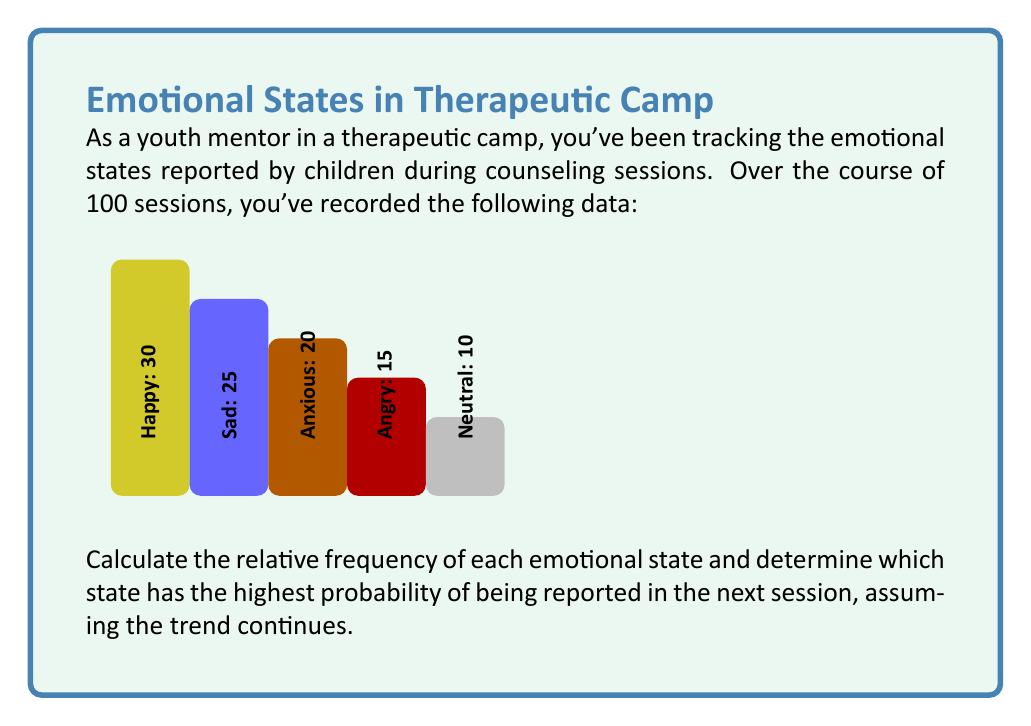Show me your answer to this math problem. To solve this problem, we need to follow these steps:

1) Calculate the total number of observations:
   $$ \text{Total} = 30 + 25 + 20 + 15 + 10 = 100 $$

2) Calculate the relative frequency for each emotional state:
   Relative frequency = Number of occurrences / Total number of observations

   For Happy: $$ f_{\text{Happy}} = \frac{30}{100} = 0.30 $$
   For Sad: $$ f_{\text{Sad}} = \frac{25}{100} = 0.25 $$
   For Anxious: $$ f_{\text{Anxious}} = \frac{20}{100} = 0.20 $$
   For Angry: $$ f_{\text{Angry}} = \frac{15}{100} = 0.15 $$
   For Neutral: $$ f_{\text{Neutral}} = \frac{10}{100} = 0.10 $$

3) The relative frequency represents the probability of each state occurring in the next session, assuming the trend continues.

4) Compare the probabilities to determine which state has the highest:

   $$ P(\text{Happy}) = 0.30 $$
   $$ P(\text{Sad}) = 0.25 $$
   $$ P(\text{Anxious}) = 0.20 $$
   $$ P(\text{Angry}) = 0.15 $$
   $$ P(\text{Neutral}) = 0.10 $$

The highest probability is 0.30, corresponding to the "Happy" state.
Answer: Happy, with a probability of 0.30 